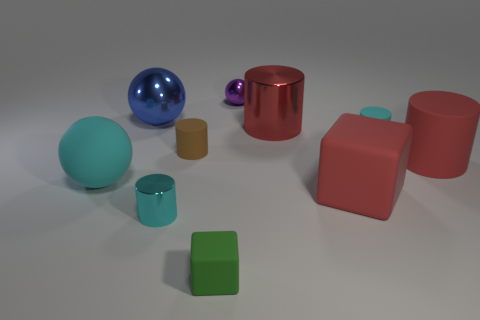What is the tiny green block made of?
Provide a short and direct response. Rubber. There is a tiny thing right of the tiny purple shiny thing; what material is it?
Give a very brief answer. Rubber. Is there any other thing that has the same material as the cyan sphere?
Provide a succinct answer. Yes. Is the number of spheres in front of the green thing greater than the number of matte things?
Provide a short and direct response. No. Is there a tiny green rubber object in front of the cyan thing left of the large sphere that is on the right side of the big cyan object?
Make the answer very short. Yes. There is a tiny brown rubber object; are there any blue shiny things in front of it?
Your answer should be compact. No. How many rubber objects have the same color as the big block?
Keep it short and to the point. 1. There is a brown object that is the same material as the red block; what size is it?
Make the answer very short. Small. What size is the rubber block that is left of the red metal cylinder right of the metallic cylinder on the left side of the green rubber cube?
Offer a terse response. Small. What size is the cyan cylinder on the right side of the tiny metal sphere?
Keep it short and to the point. Small. 